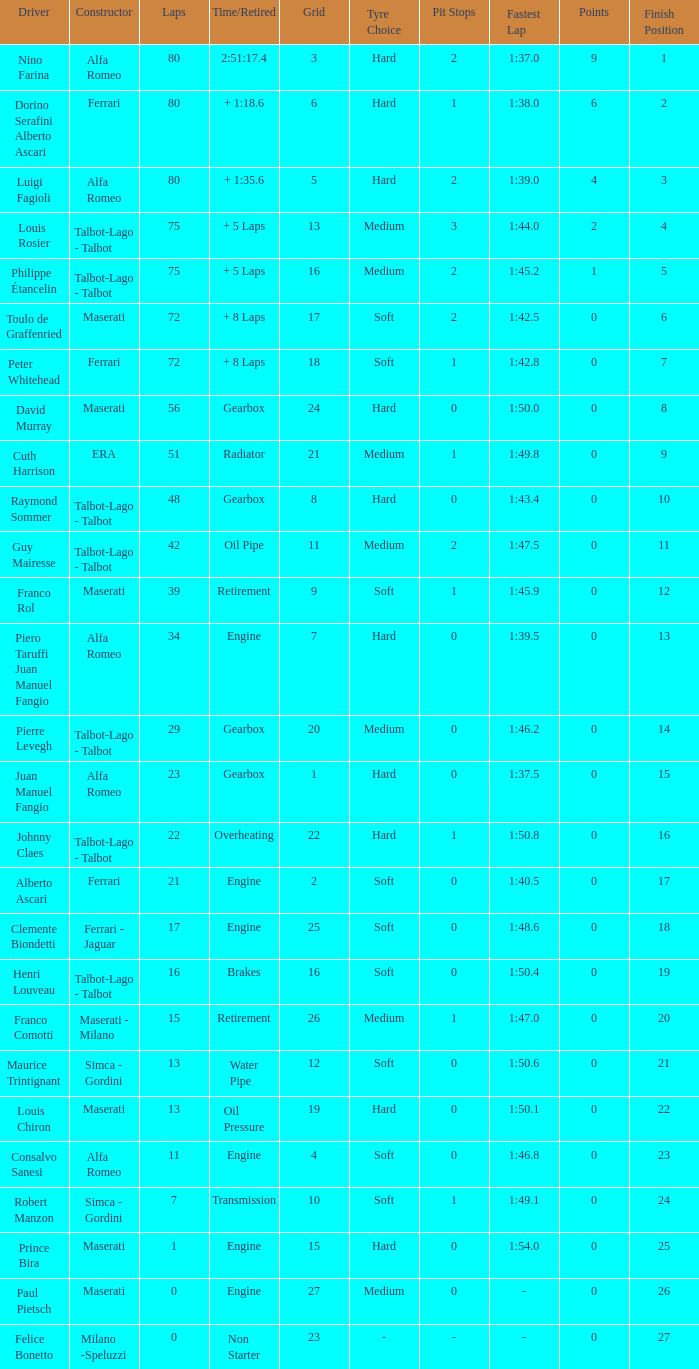Help me parse the entirety of this table. {'header': ['Driver', 'Constructor', 'Laps', 'Time/Retired', 'Grid', 'Tyre Choice', 'Pit Stops', 'Fastest Lap', 'Points', 'Finish Position'], 'rows': [['Nino Farina', 'Alfa Romeo', '80', '2:51:17.4', '3', 'Hard', '2', '1:37.0', '9', '1'], ['Dorino Serafini Alberto Ascari', 'Ferrari', '80', '+ 1:18.6', '6', 'Hard', '1', '1:38.0', '6', '2'], ['Luigi Fagioli', 'Alfa Romeo', '80', '+ 1:35.6', '5', 'Hard', '2', '1:39.0', '4', '3'], ['Louis Rosier', 'Talbot-Lago - Talbot', '75', '+ 5 Laps', '13', 'Medium', '3', '1:44.0', '2', '4'], ['Philippe Étancelin', 'Talbot-Lago - Talbot', '75', '+ 5 Laps', '16', 'Medium', '2', '1:45.2', '1', '5'], ['Toulo de Graffenried', 'Maserati', '72', '+ 8 Laps', '17', 'Soft', '2', '1:42.5', '0', '6'], ['Peter Whitehead', 'Ferrari', '72', '+ 8 Laps', '18', 'Soft', '1', '1:42.8', '0', '7'], ['David Murray', 'Maserati', '56', 'Gearbox', '24', 'Hard', '0', '1:50.0', '0', '8'], ['Cuth Harrison', 'ERA', '51', 'Radiator', '21', 'Medium', '1', '1:49.8', '0', '9'], ['Raymond Sommer', 'Talbot-Lago - Talbot', '48', 'Gearbox', '8', 'Hard', '0', '1:43.4', '0', '10'], ['Guy Mairesse', 'Talbot-Lago - Talbot', '42', 'Oil Pipe', '11', 'Medium', '2', '1:47.5', '0', '11'], ['Franco Rol', 'Maserati', '39', 'Retirement', '9', 'Soft', '1', '1:45.9', '0', '12'], ['Piero Taruffi Juan Manuel Fangio', 'Alfa Romeo', '34', 'Engine', '7', 'Hard', '0', '1:39.5', '0', '13'], ['Pierre Levegh', 'Talbot-Lago - Talbot', '29', 'Gearbox', '20', 'Medium', '0', '1:46.2', '0', '14'], ['Juan Manuel Fangio', 'Alfa Romeo', '23', 'Gearbox', '1', 'Hard', '0', '1:37.5', '0', '15'], ['Johnny Claes', 'Talbot-Lago - Talbot', '22', 'Overheating', '22', 'Hard', '1', '1:50.8', '0', '16'], ['Alberto Ascari', 'Ferrari', '21', 'Engine', '2', 'Soft', '0', '1:40.5', '0', '17'], ['Clemente Biondetti', 'Ferrari - Jaguar', '17', 'Engine', '25', 'Soft', '0', '1:48.6', '0', '18'], ['Henri Louveau', 'Talbot-Lago - Talbot', '16', 'Brakes', '16', 'Soft', '0', '1:50.4', '0', '19'], ['Franco Comotti', 'Maserati - Milano', '15', 'Retirement', '26', 'Medium', '1', '1:47.0', '0', '20'], ['Maurice Trintignant', 'Simca - Gordini', '13', 'Water Pipe', '12', 'Soft', '0', '1:50.6', '0', '21'], ['Louis Chiron', 'Maserati', '13', 'Oil Pressure', '19', 'Hard', '0', '1:50.1', '0', '22'], ['Consalvo Sanesi', 'Alfa Romeo', '11', 'Engine', '4', 'Soft', '0', '1:46.8', '0', '23'], ['Robert Manzon', 'Simca - Gordini', '7', 'Transmission', '10', 'Soft', '1', '1:49.1', '0', '24'], ['Prince Bira', 'Maserati', '1', 'Engine', '15', 'Hard', '0', '1:54.0', '0', '25'], ['Paul Pietsch', 'Maserati', '0', 'Engine', '27', 'Medium', '0', '-', '0', '26'], ['Felice Bonetto', 'Milano -Speluzzi', '0', 'Non Starter', '23', '-', '-', '-', '0', '27']]} When the driver is Juan Manuel Fangio and laps is less than 39, what is the highest grid? 1.0. 